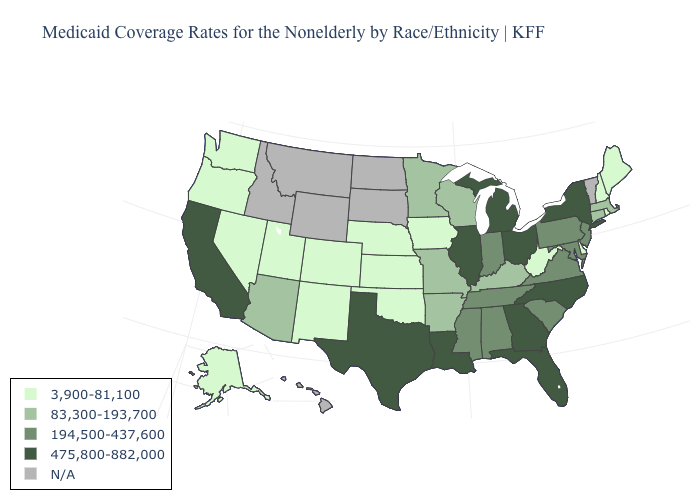What is the value of Delaware?
Write a very short answer. 3,900-81,100. What is the value of Mississippi?
Give a very brief answer. 194,500-437,600. Does Michigan have the highest value in the USA?
Keep it brief. Yes. Does New York have the lowest value in the USA?
Short answer required. No. What is the value of Arizona?
Keep it brief. 83,300-193,700. Name the states that have a value in the range 3,900-81,100?
Answer briefly. Alaska, Colorado, Delaware, Iowa, Kansas, Maine, Nebraska, Nevada, New Hampshire, New Mexico, Oklahoma, Oregon, Rhode Island, Utah, Washington, West Virginia. What is the value of New Jersey?
Concise answer only. 194,500-437,600. What is the value of Connecticut?
Answer briefly. 83,300-193,700. Name the states that have a value in the range N/A?
Short answer required. Hawaii, Idaho, Montana, North Dakota, South Dakota, Vermont, Wyoming. What is the lowest value in the West?
Quick response, please. 3,900-81,100. Name the states that have a value in the range 194,500-437,600?
Write a very short answer. Alabama, Indiana, Maryland, Mississippi, New Jersey, Pennsylvania, South Carolina, Tennessee, Virginia. What is the value of Michigan?
Answer briefly. 475,800-882,000. Name the states that have a value in the range 3,900-81,100?
Write a very short answer. Alaska, Colorado, Delaware, Iowa, Kansas, Maine, Nebraska, Nevada, New Hampshire, New Mexico, Oklahoma, Oregon, Rhode Island, Utah, Washington, West Virginia. 